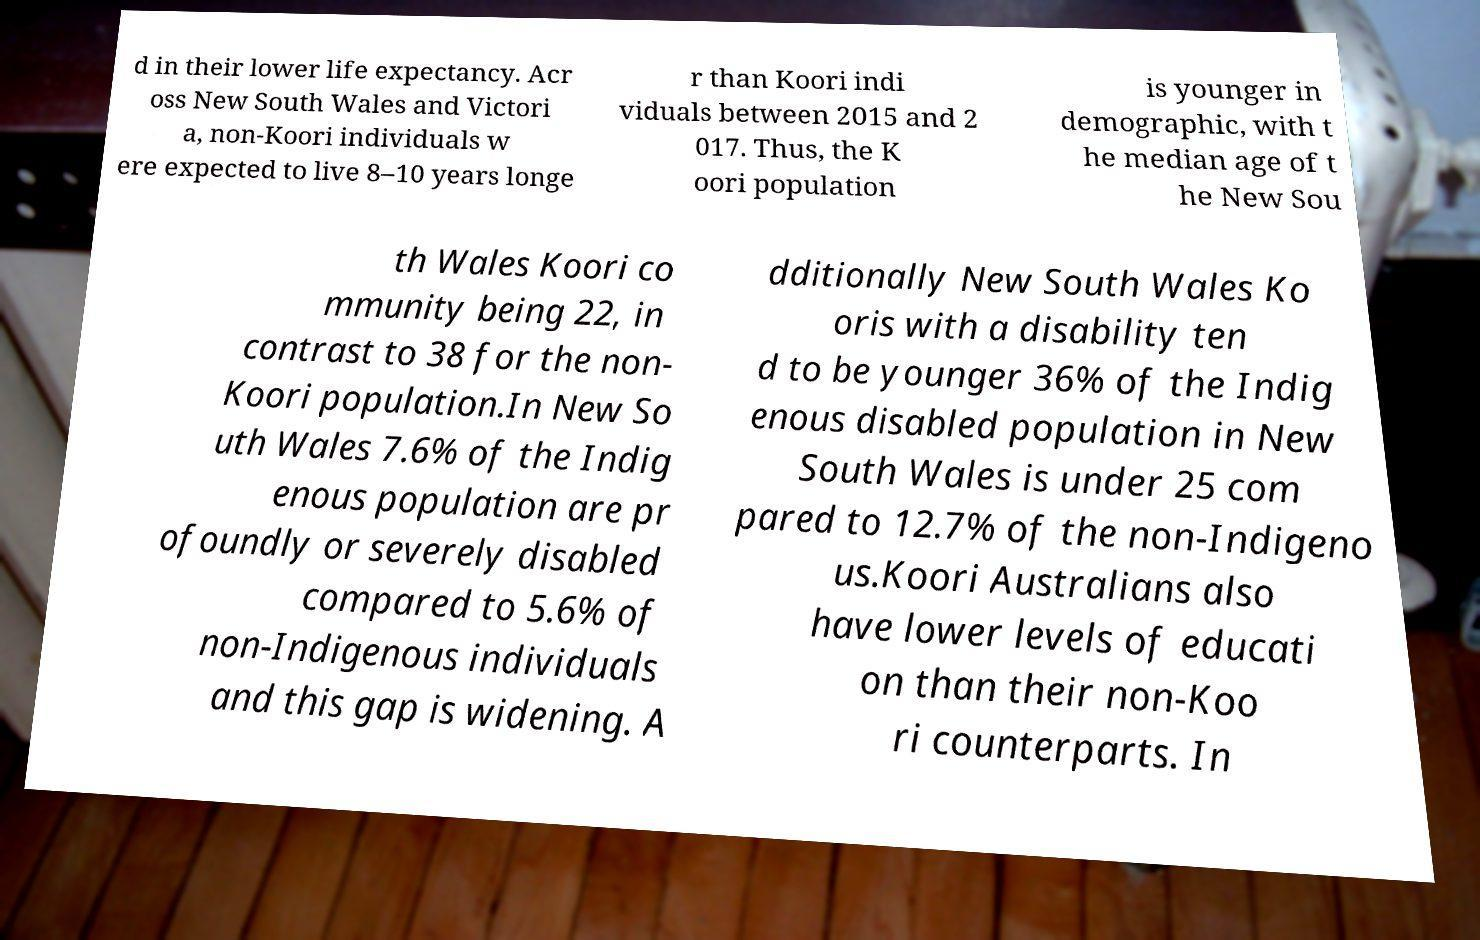Can you accurately transcribe the text from the provided image for me? d in their lower life expectancy. Acr oss New South Wales and Victori a, non-Koori individuals w ere expected to live 8–10 years longe r than Koori indi viduals between 2015 and 2 017. Thus, the K oori population is younger in demographic, with t he median age of t he New Sou th Wales Koori co mmunity being 22, in contrast to 38 for the non- Koori population.In New So uth Wales 7.6% of the Indig enous population are pr ofoundly or severely disabled compared to 5.6% of non-Indigenous individuals and this gap is widening. A dditionally New South Wales Ko oris with a disability ten d to be younger 36% of the Indig enous disabled population in New South Wales is under 25 com pared to 12.7% of the non-Indigeno us.Koori Australians also have lower levels of educati on than their non-Koo ri counterparts. In 